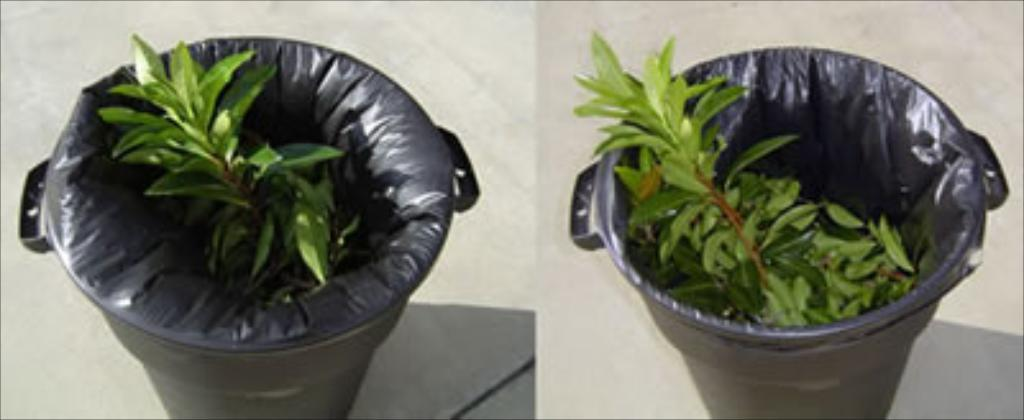What objects are in the image that are used for waste disposal? There are bins in the image that are used for waste disposal. What materials are inside the bins? The bins contain leaves and plastic covers. Where are the bins located? The bins are placed on a platform. Can you see anyone jumping over the bins in the image? There is no one jumping over the bins in the image. 